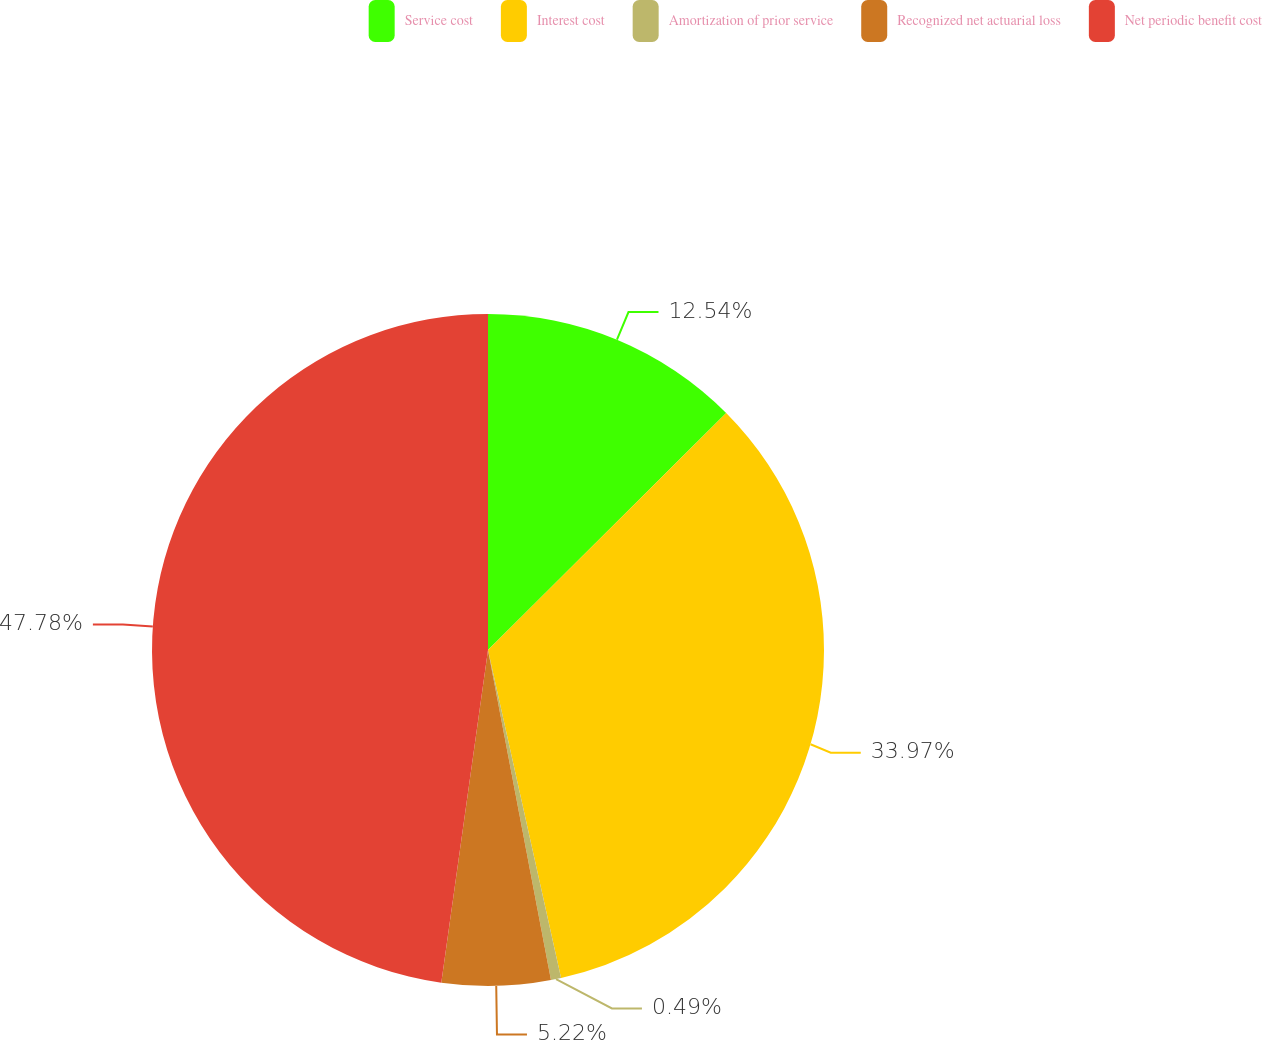<chart> <loc_0><loc_0><loc_500><loc_500><pie_chart><fcel>Service cost<fcel>Interest cost<fcel>Amortization of prior service<fcel>Recognized net actuarial loss<fcel>Net periodic benefit cost<nl><fcel>12.54%<fcel>33.97%<fcel>0.49%<fcel>5.22%<fcel>47.78%<nl></chart> 